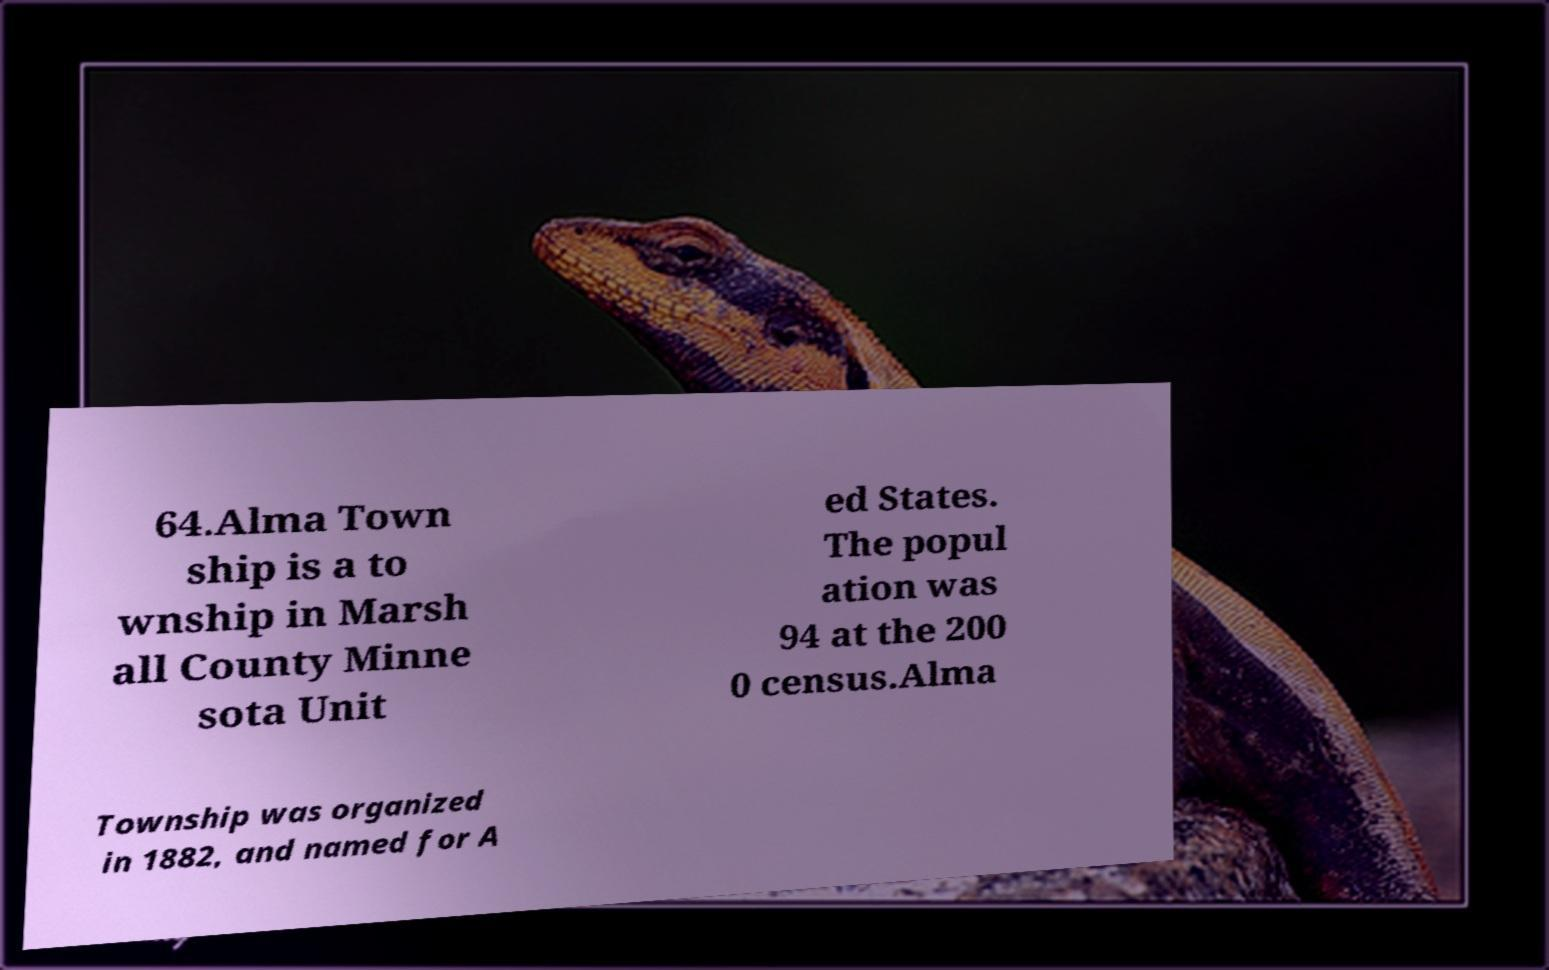Could you extract and type out the text from this image? 64.Alma Town ship is a to wnship in Marsh all County Minne sota Unit ed States. The popul ation was 94 at the 200 0 census.Alma Township was organized in 1882, and named for A 